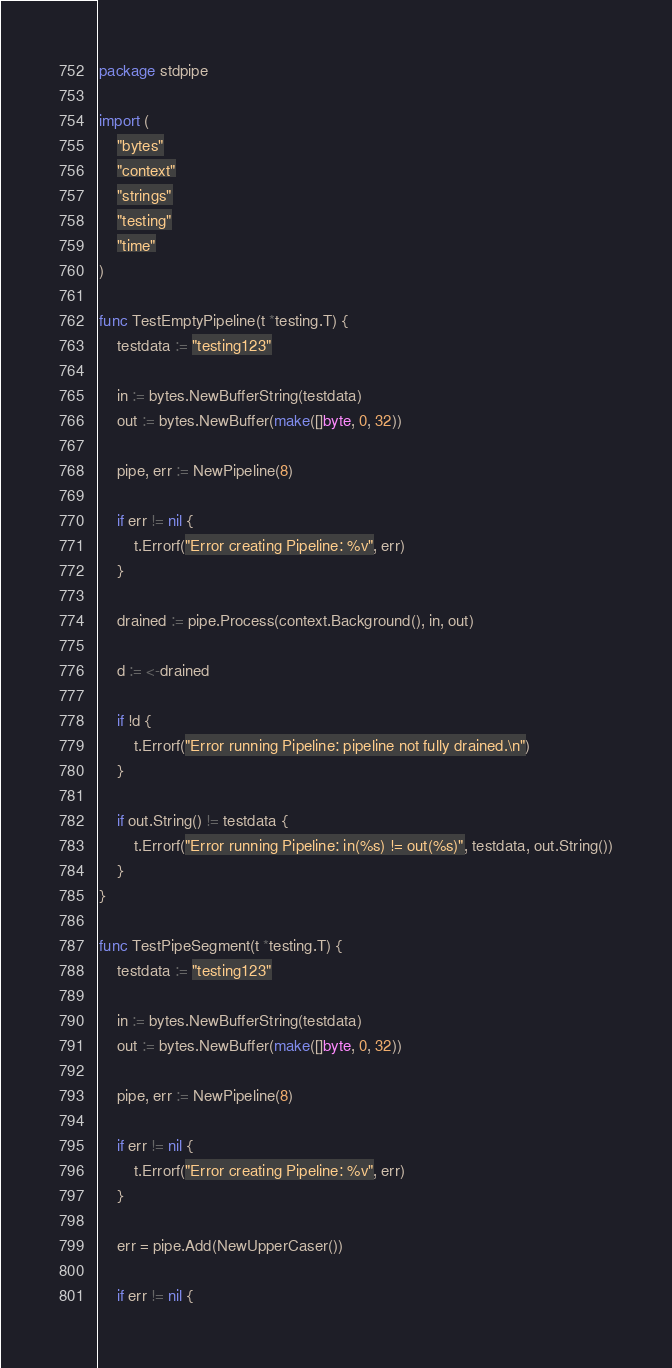Convert code to text. <code><loc_0><loc_0><loc_500><loc_500><_Go_>package stdpipe

import (
	"bytes"
	"context"
	"strings"
	"testing"
	"time"
)

func TestEmptyPipeline(t *testing.T) {
	testdata := "testing123"

	in := bytes.NewBufferString(testdata)
	out := bytes.NewBuffer(make([]byte, 0, 32))

	pipe, err := NewPipeline(8)

	if err != nil {
		t.Errorf("Error creating Pipeline: %v", err)
	}

	drained := pipe.Process(context.Background(), in, out)

	d := <-drained

	if !d {
		t.Errorf("Error running Pipeline: pipeline not fully drained.\n")
	}

	if out.String() != testdata {
		t.Errorf("Error running Pipeline: in(%s) != out(%s)", testdata, out.String())
	}
}

func TestPipeSegment(t *testing.T) {
	testdata := "testing123"

	in := bytes.NewBufferString(testdata)
	out := bytes.NewBuffer(make([]byte, 0, 32))

	pipe, err := NewPipeline(8)

	if err != nil {
		t.Errorf("Error creating Pipeline: %v", err)
	}

	err = pipe.Add(NewUpperCaser())

	if err != nil {</code> 